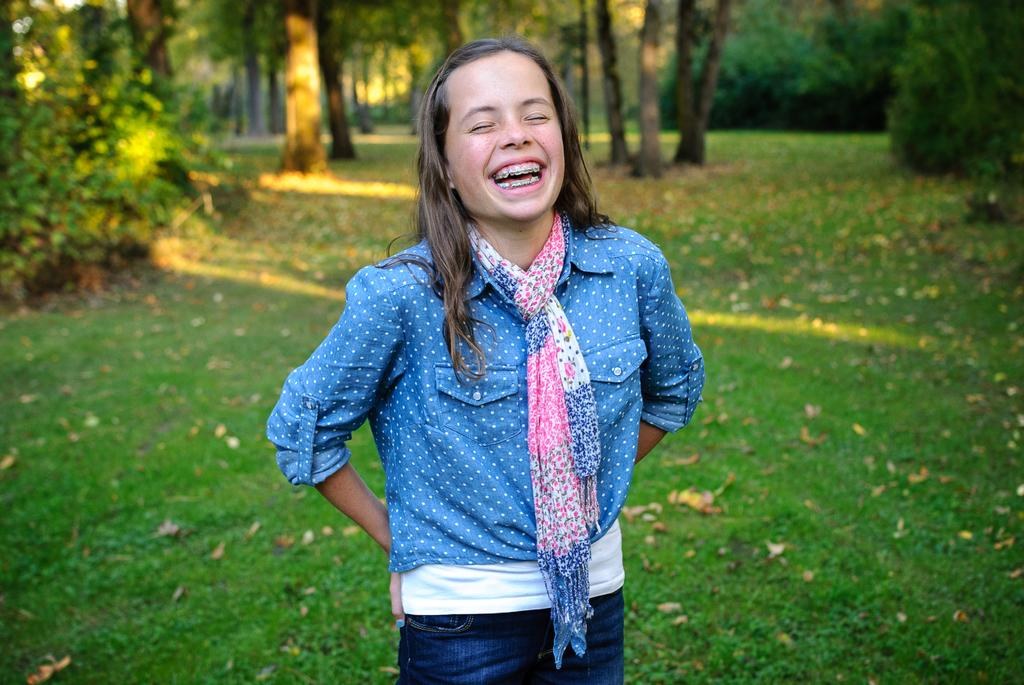Who is present in the image? A: There is a girl in the image. What is the girl doing in the image? The girl is smiling. What is the girl wearing in the image? The girl is wearing a blue shirt and blue trousers. What type of environment is visible in the image? There is grass visible in the image, and trees are in the background. What type of vessel is the girl using to lift the blade in the image? There is no vessel, lifting, or blade present in the image. 